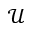Convert formula to latex. <formula><loc_0><loc_0><loc_500><loc_500>\mathcal { U }</formula> 